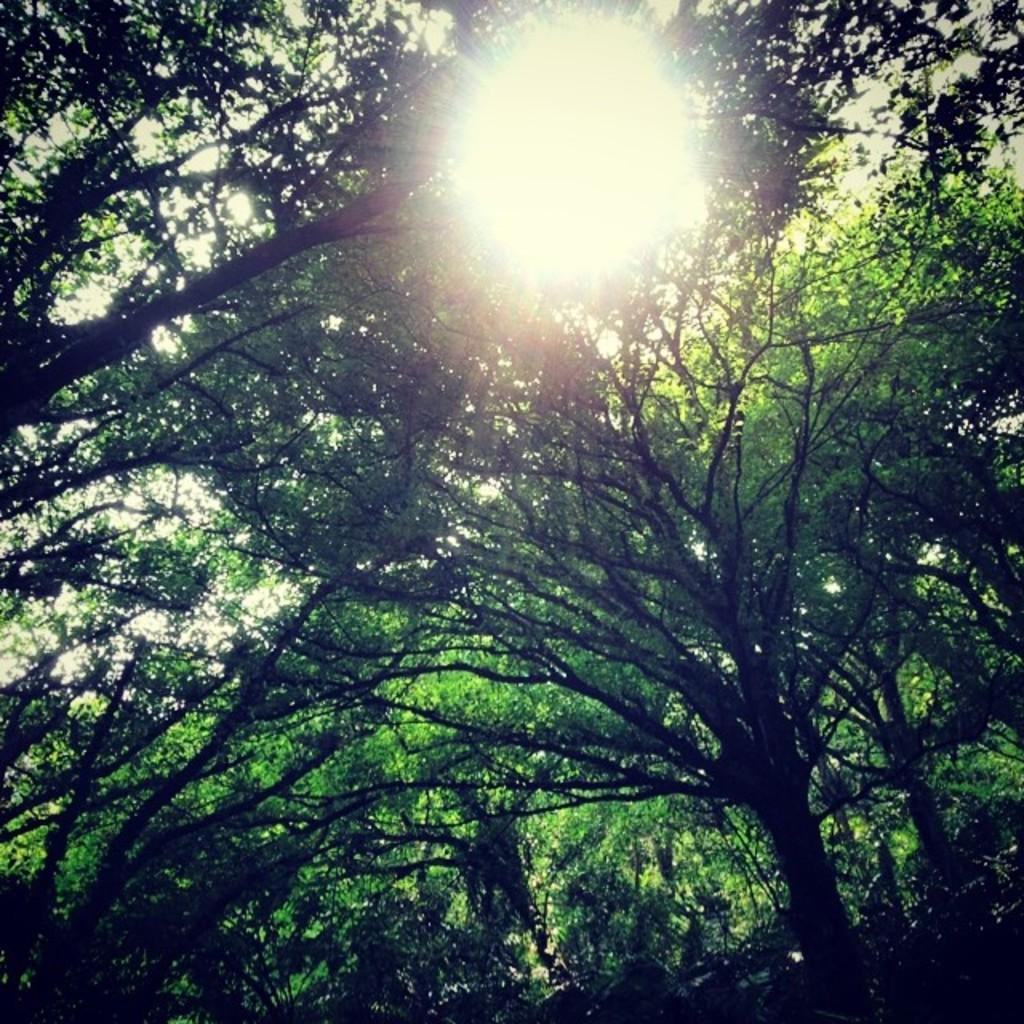What type of natural environment is depicted in the image? There are many trees in the image, suggesting a forest or wooded area. What celestial body can be seen in the image? The sun is visible in the image. What else is visible in the image besides the trees and sun? The sky is visible in the image. What type of truck is parked near the trees in the image? There is no truck present in the image; it only features trees, the sun, and the sky. 